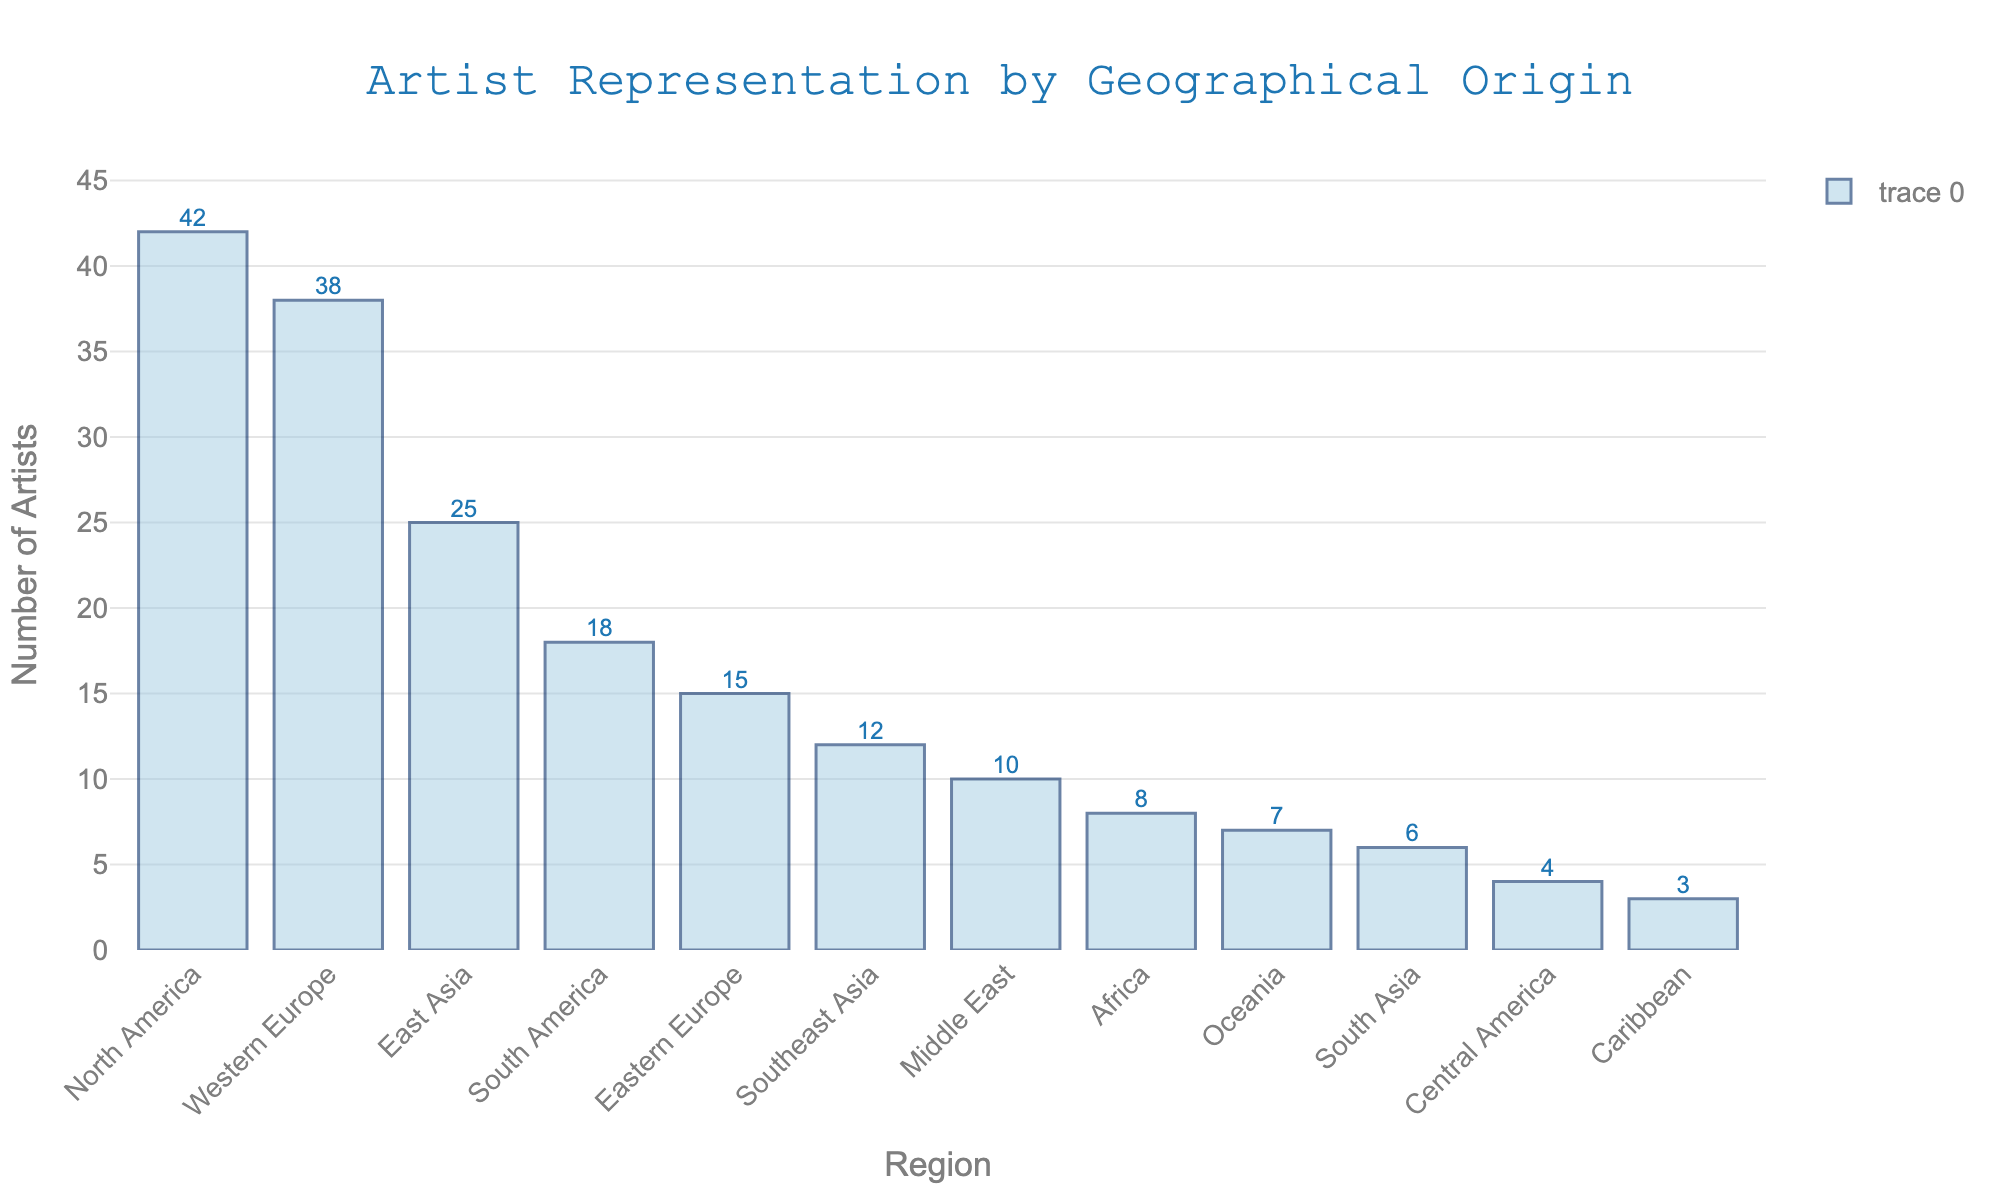Which region has the highest number of artists represented in the gallery's collection? North America has the highest bar in the chart, indicating it has the most artists.
Answer: North America How many more artists are represented from Western Europe compared to Eastern Europe? The bar for Western Europe shows 38 artists, and Eastern Europe shows 15 artists. The difference is 38 - 15 = 23.
Answer: 23 What's the total number of artists represented from any three regions of your choice? Let's choose North America (42), South America (18), and Africa (8). Sum these values: 42 + 18 + 8 = 68.
Answer: 68 Which region has the least number of artists? The bar for the Caribbean has the smallest height, indicating it has the fewest artists.
Answer: Caribbean How many artists are represented from regions that have fewer than 10 artists each? These regions are Middle East (10 - excluded), Africa (8), Oceania (7), South Asia (6), Central America (4), Caribbean (3). Sum: 8 + 7 + 6 + 4 + 3 = 28.
Answer: 28 Which regions have almost equal representation, having numbers within a two-artist margin of each other? East Asia (25) and South America (18) are not within a two-artist margin. However, Southeast Asia (12) and Middle East (10) are.
Answer: Southeast Asia, Middle East If you combine the artists from regions with less than 15 artists each, what would be the new total? Regions: Eastern Europe (15), Southeast Asia (12), Middle East (10), Africa (8), Oceania (7), South Asia (6), Central America (4), Caribbean (3). Sum: 15 + 12 + 10 + 8 + 7 + 6 + 4 + 3 = 65.
Answer: 65 Which region has the fourth highest representation of artists? The sorted order from highest to lowest is: North America, Western Europe, East Asia, South America. So, South America has the fourth highest.
Answer: South America What is the average number of artists represented per region? There are 12 regions in total and the sum of all artists is 188 (sum of all values). So, the average is 188 / 12 ≈ 15.67.
Answer: 15.67 How does the representation of artists from Central America compare to that of Southeast Asia? The bar for Central America represents 4 artists, while Southeast Asia represents 12 artists. Central America has fewer artists.
Answer: Southeast Asia has more artists 